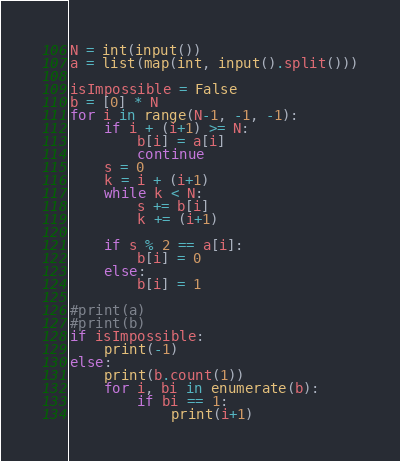<code> <loc_0><loc_0><loc_500><loc_500><_Python_>N = int(input())
a = list(map(int, input().split()))

isImpossible = False
b = [0] * N
for i in range(N-1, -1, -1):
    if i + (i+1) >= N:
        b[i] = a[i]
        continue
    s = 0
    k = i + (i+1)
    while k < N:
        s += b[i]
        k += (i+1)

    if s % 2 == a[i]:
        b[i] = 0
    else:
        b[i] = 1

#print(a)
#print(b)
if isImpossible:
    print(-1)
else:
    print(b.count(1))
    for i, bi in enumerate(b):
        if bi == 1:
            print(i+1)
</code> 